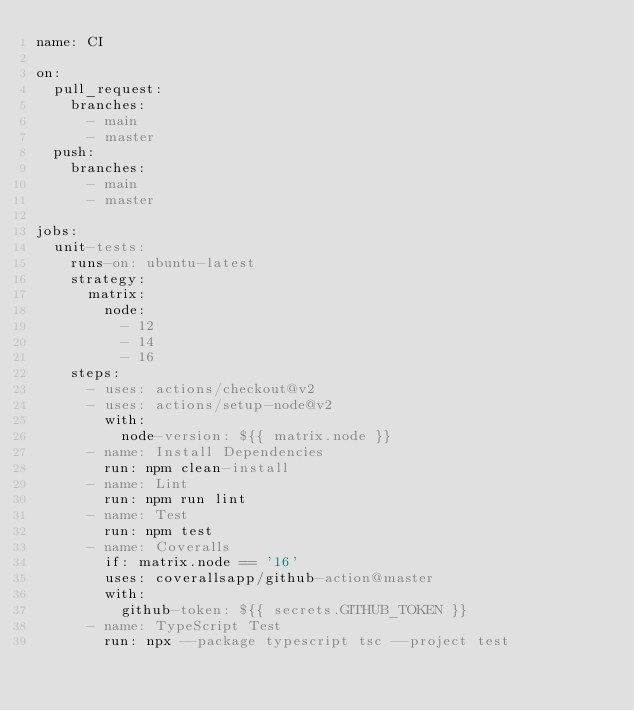Convert code to text. <code><loc_0><loc_0><loc_500><loc_500><_YAML_>name: CI

on:
  pull_request:
    branches:
      - main
      - master
  push:
    branches:
      - main
      - master

jobs:
  unit-tests:
    runs-on: ubuntu-latest
    strategy:
      matrix:
        node:
          - 12
          - 14
          - 16
    steps:
      - uses: actions/checkout@v2
      - uses: actions/setup-node@v2
        with:
          node-version: ${{ matrix.node }}
      - name: Install Dependencies
        run: npm clean-install
      - name: Lint
        run: npm run lint
      - name: Test
        run: npm test
      - name: Coveralls
        if: matrix.node == '16'
        uses: coverallsapp/github-action@master
        with:
          github-token: ${{ secrets.GITHUB_TOKEN }}
      - name: TypeScript Test
        run: npx --package typescript tsc --project test
</code> 